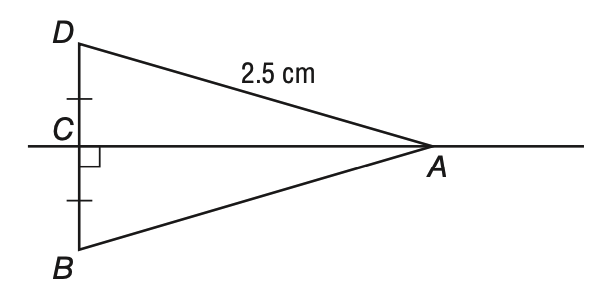Question: According to the Perpendicular Bisector Theorem, what is the length of segment A B below?
Choices:
A. 2.5
B. 3.0
C. 4.0
D. 5.0
Answer with the letter. Answer: A 